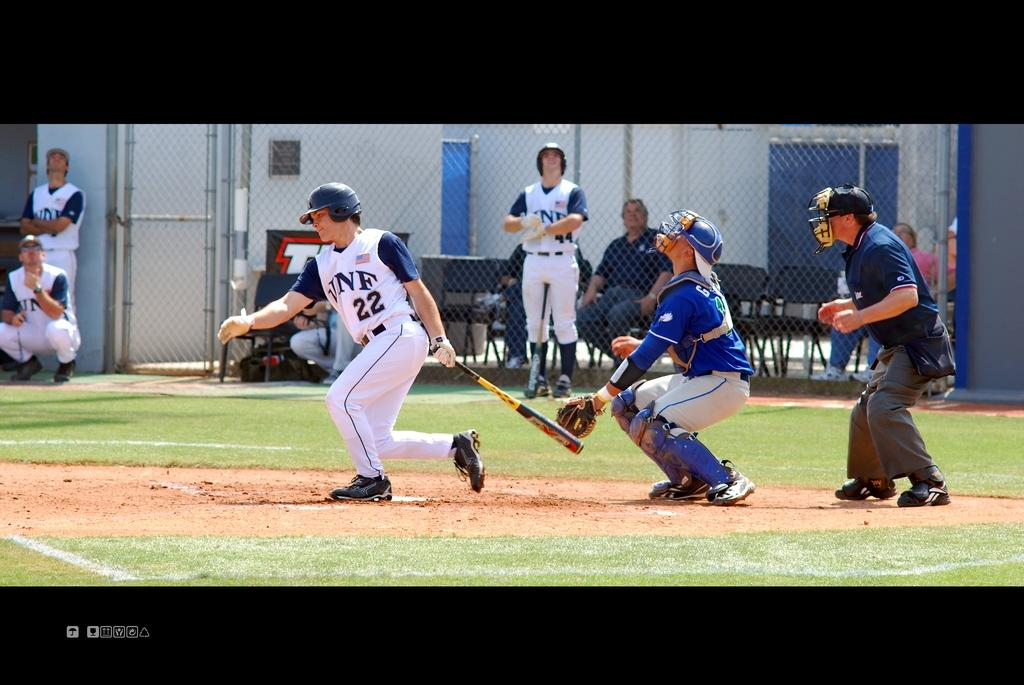Provide a one-sentence caption for the provided image. Player number 22 is dropping his bat in preparation to run the bases. 